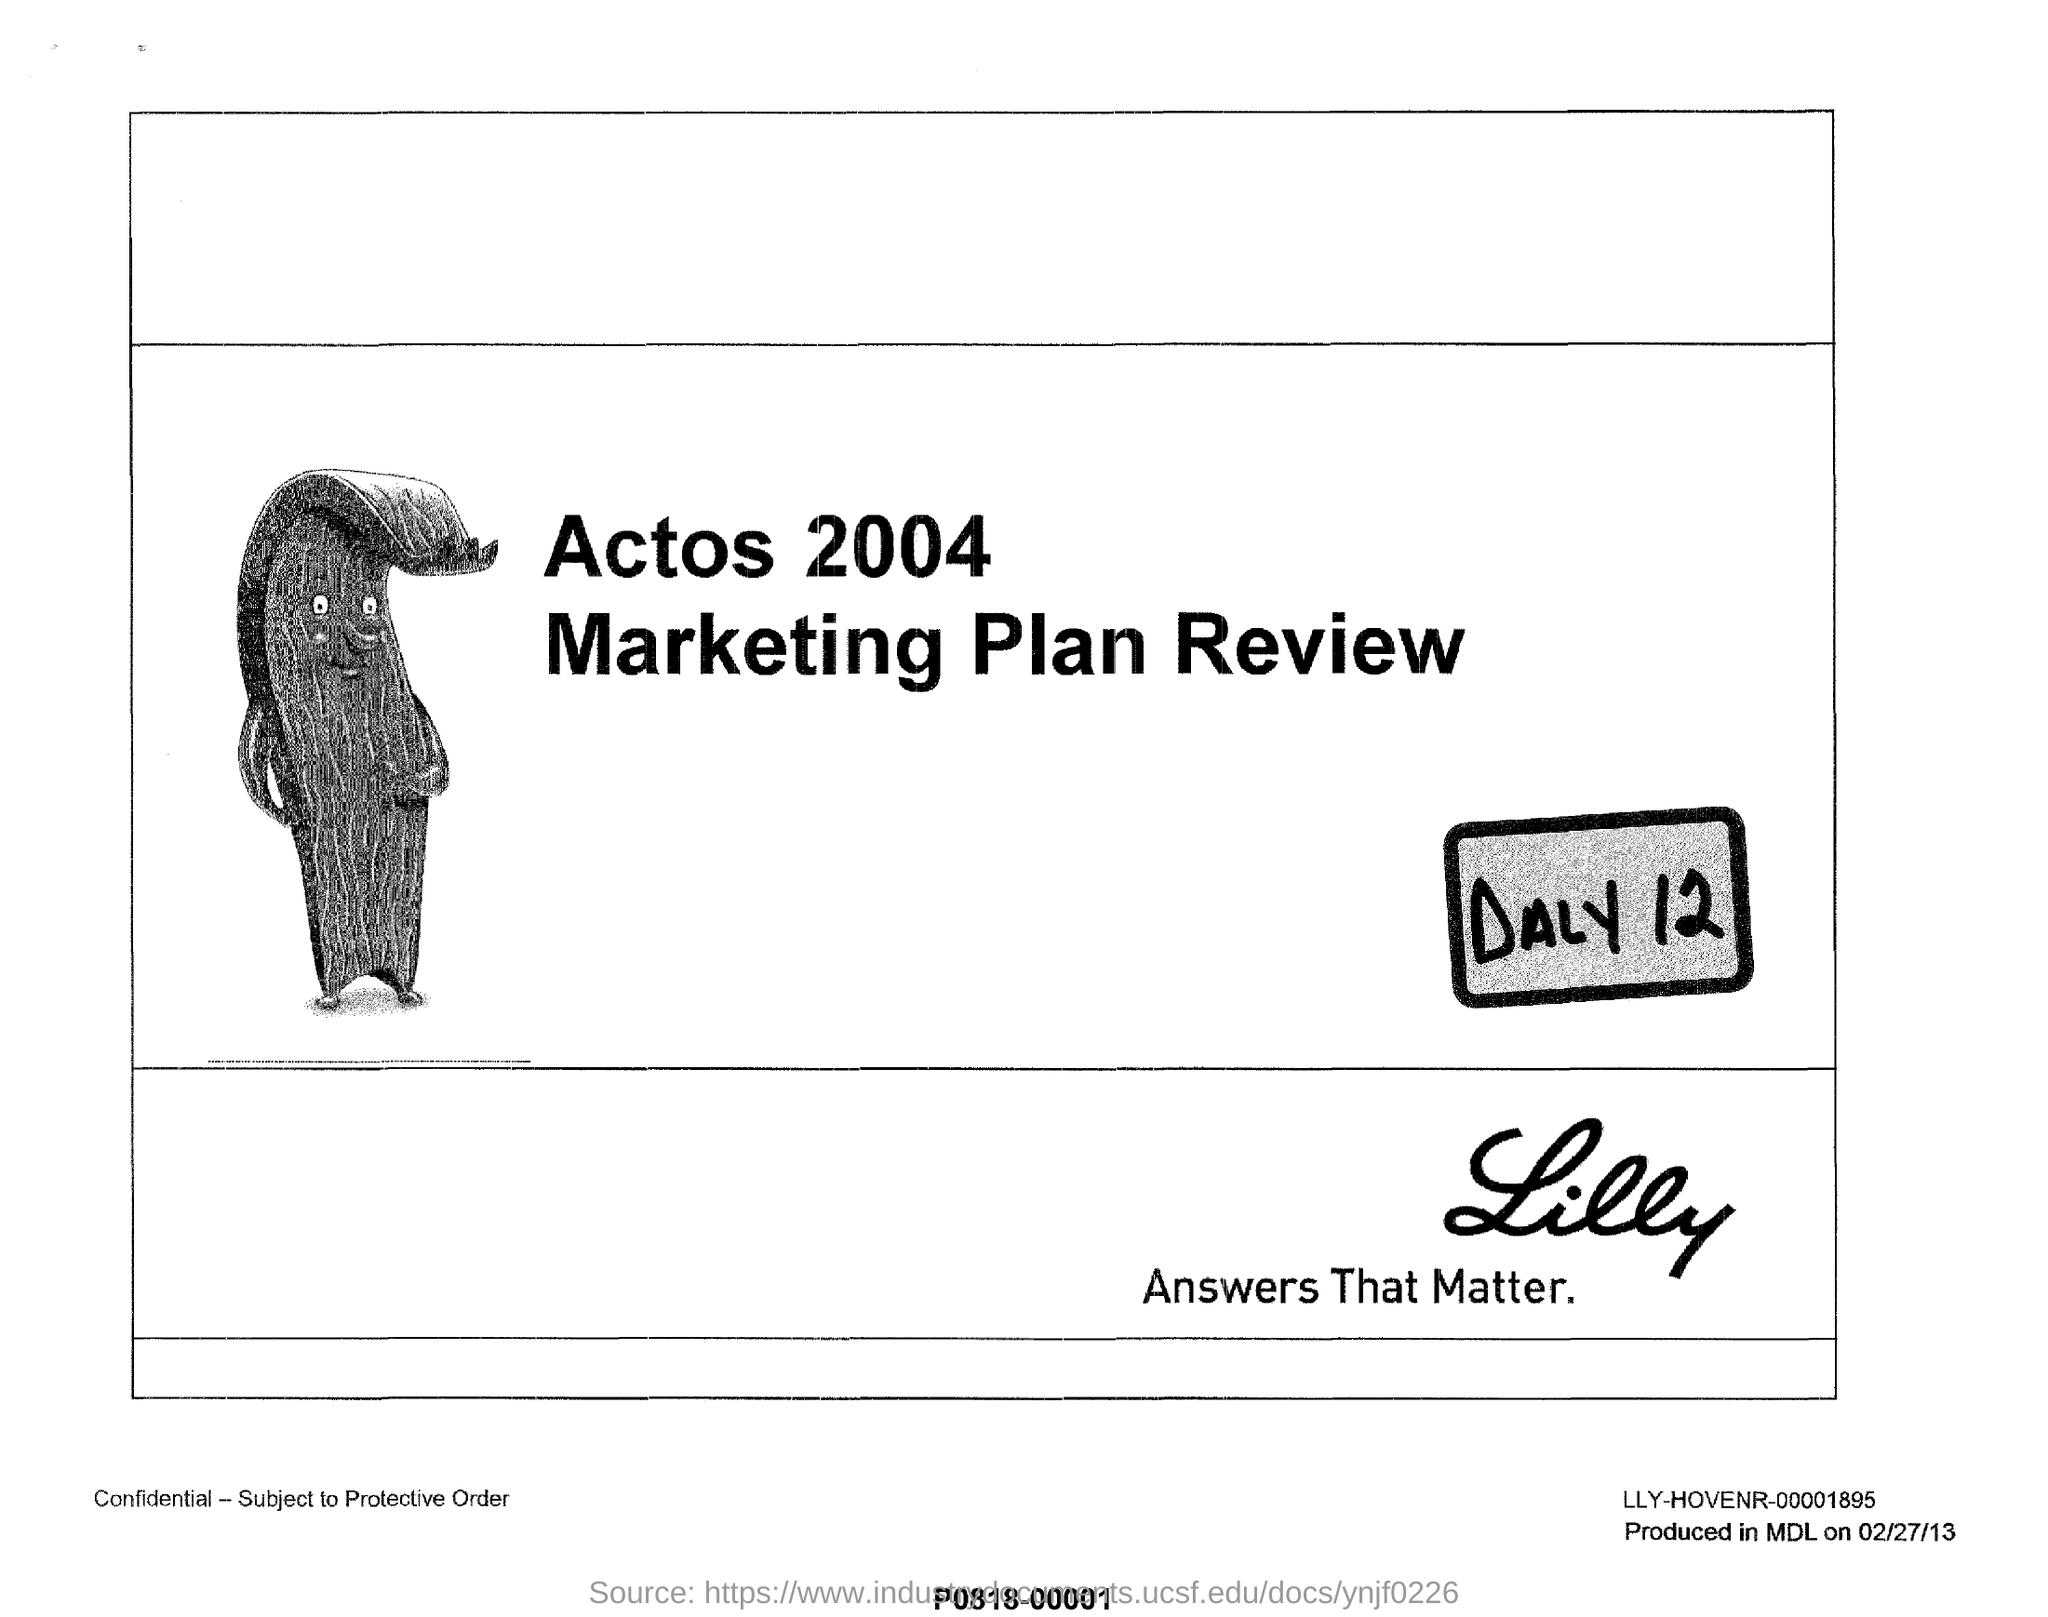What is the name of the plan review ?
Keep it short and to the point. Marketing plan review. Mention the year given for Actos?
Provide a short and direct response. 2004. 